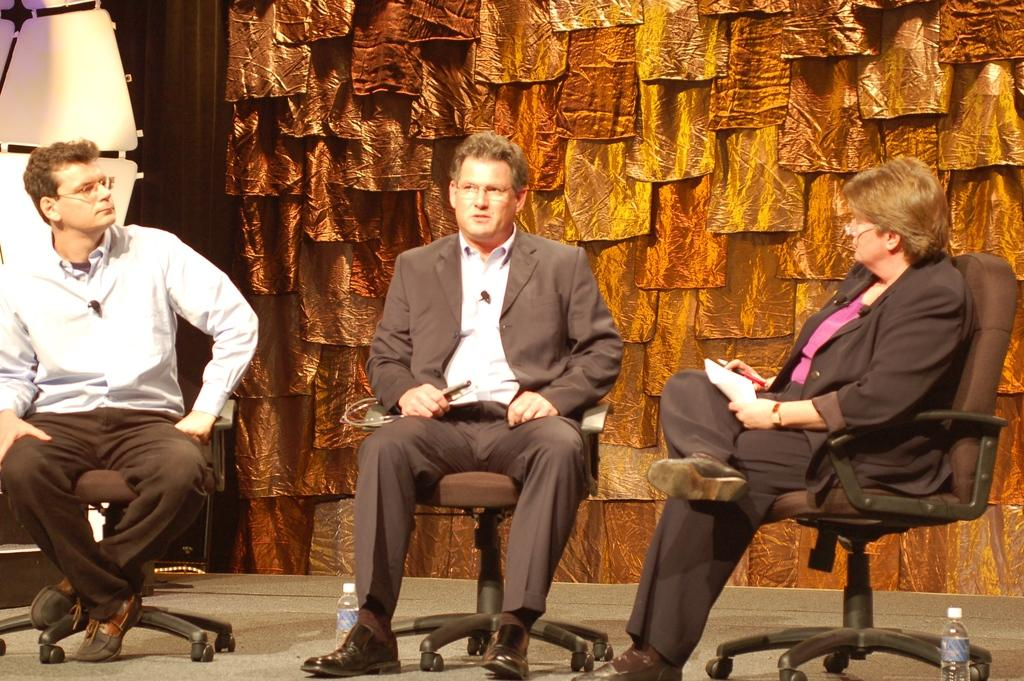How many people are in the image? There are three people in the image. What are the three people doing in the image? The three people are sitting on a chair. Can you describe the woman in the image? The woman is in the image, and she is holding a paper in her hand. What type of skirt is the woman wearing in the image? There is no information about the woman's skirt in the image. How long does it take for the pancake to cook in the image? There is no pancake present in the image. 